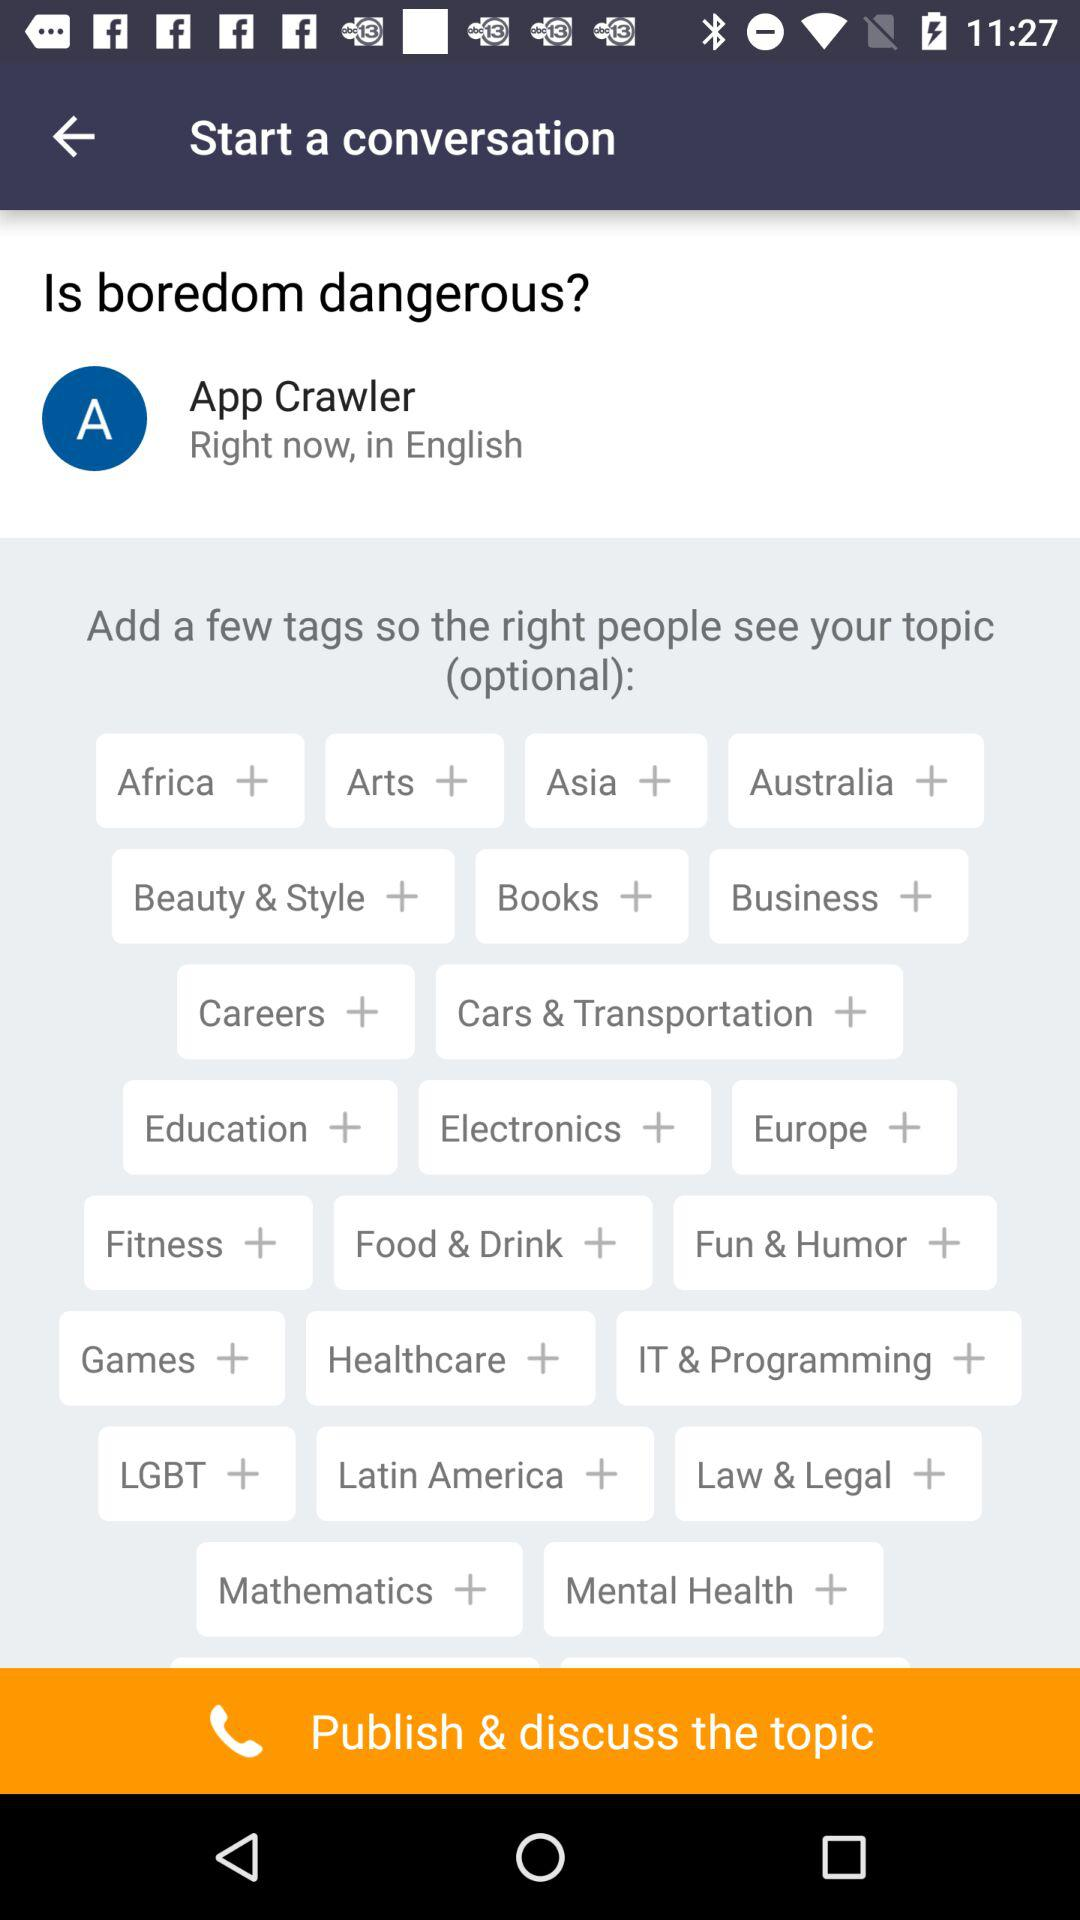What is the user name? The user name is App Crawler. 